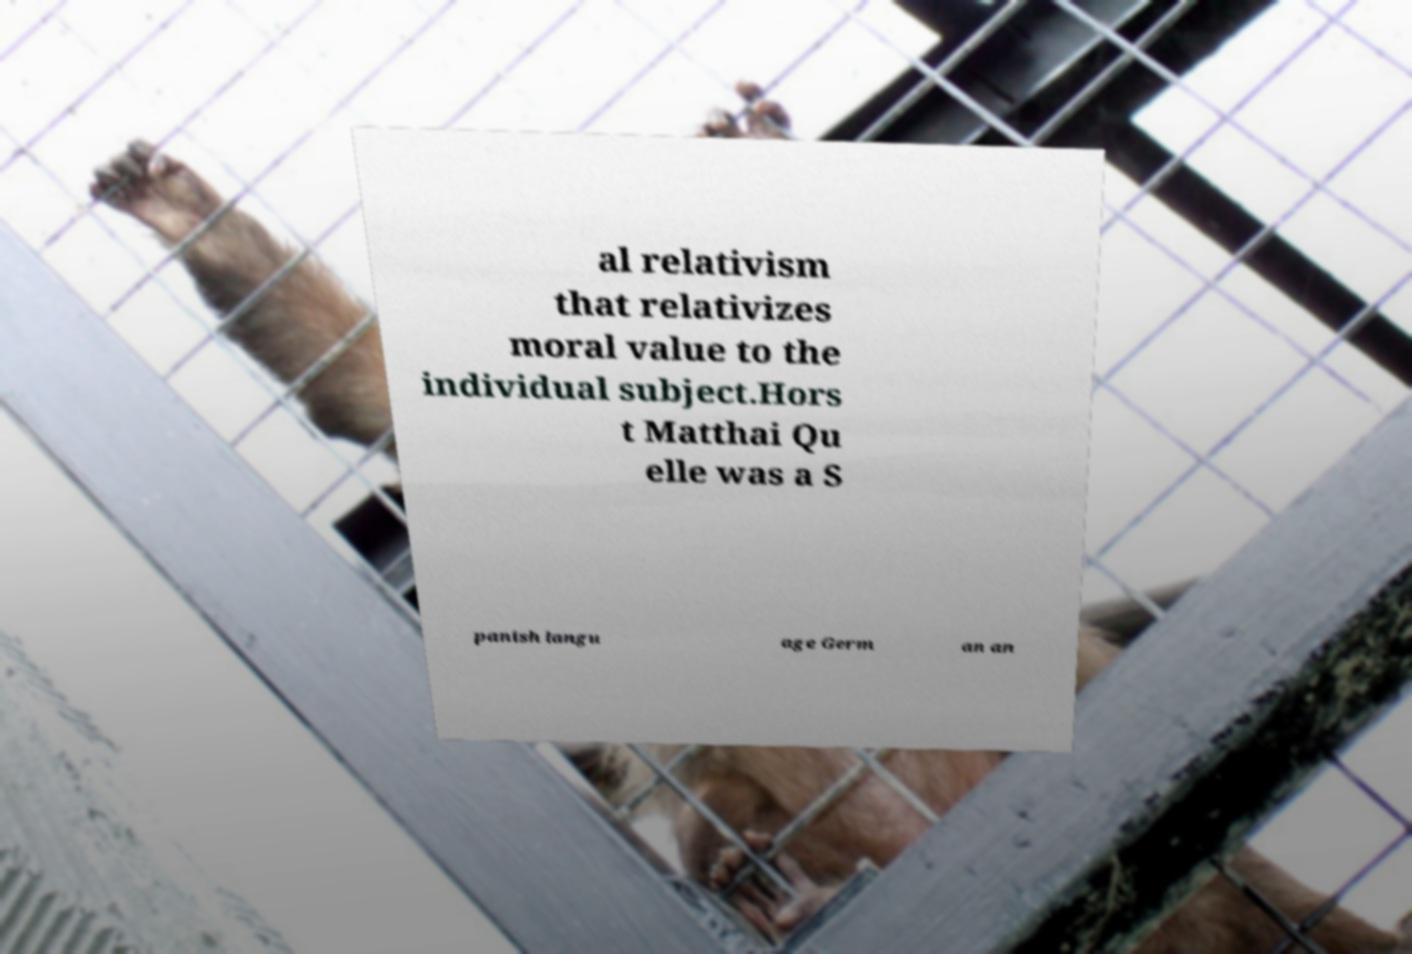What messages or text are displayed in this image? I need them in a readable, typed format. al relativism that relativizes moral value to the individual subject.Hors t Matthai Qu elle was a S panish langu age Germ an an 